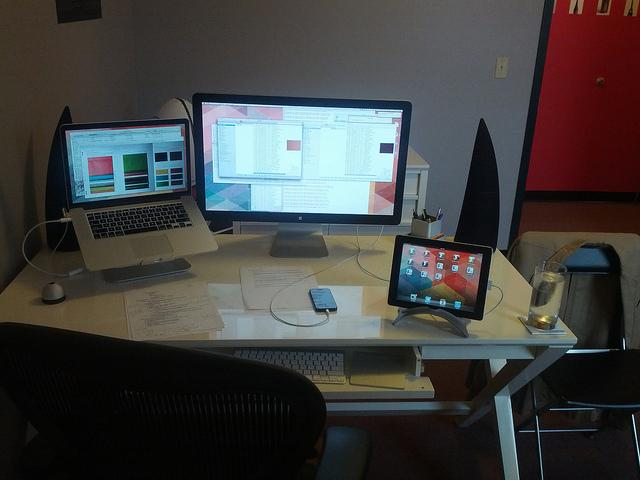What is on the table? Please explain your reasoning. laptop. There is a folding computer next to the large screen. 